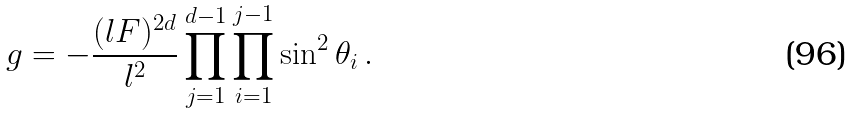<formula> <loc_0><loc_0><loc_500><loc_500>g = - \frac { ( l F ) ^ { 2 d } } { l ^ { 2 } } \prod _ { j = 1 } ^ { d - 1 } \prod _ { i = 1 } ^ { j - 1 } \sin ^ { 2 } \theta _ { i } \, .</formula> 